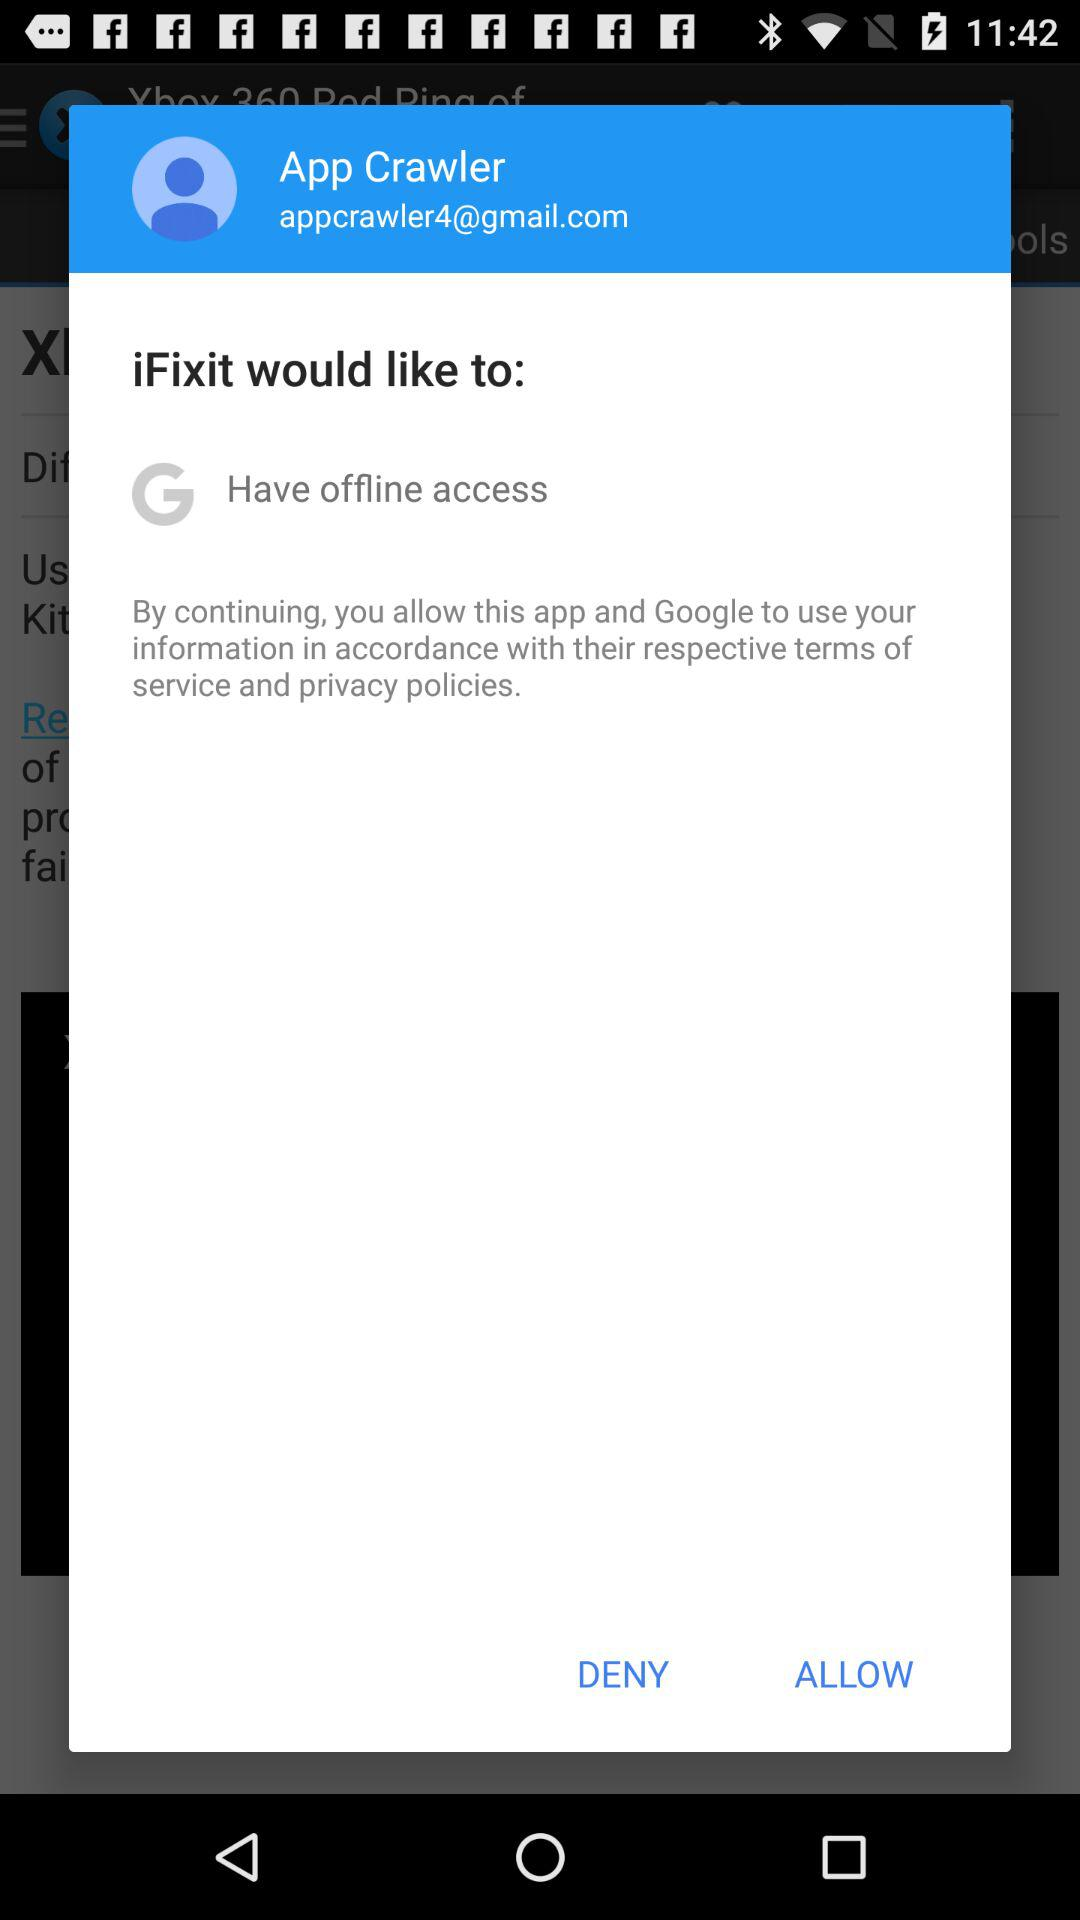What is the email address? The email address is appcrawler4@gmail.com. 